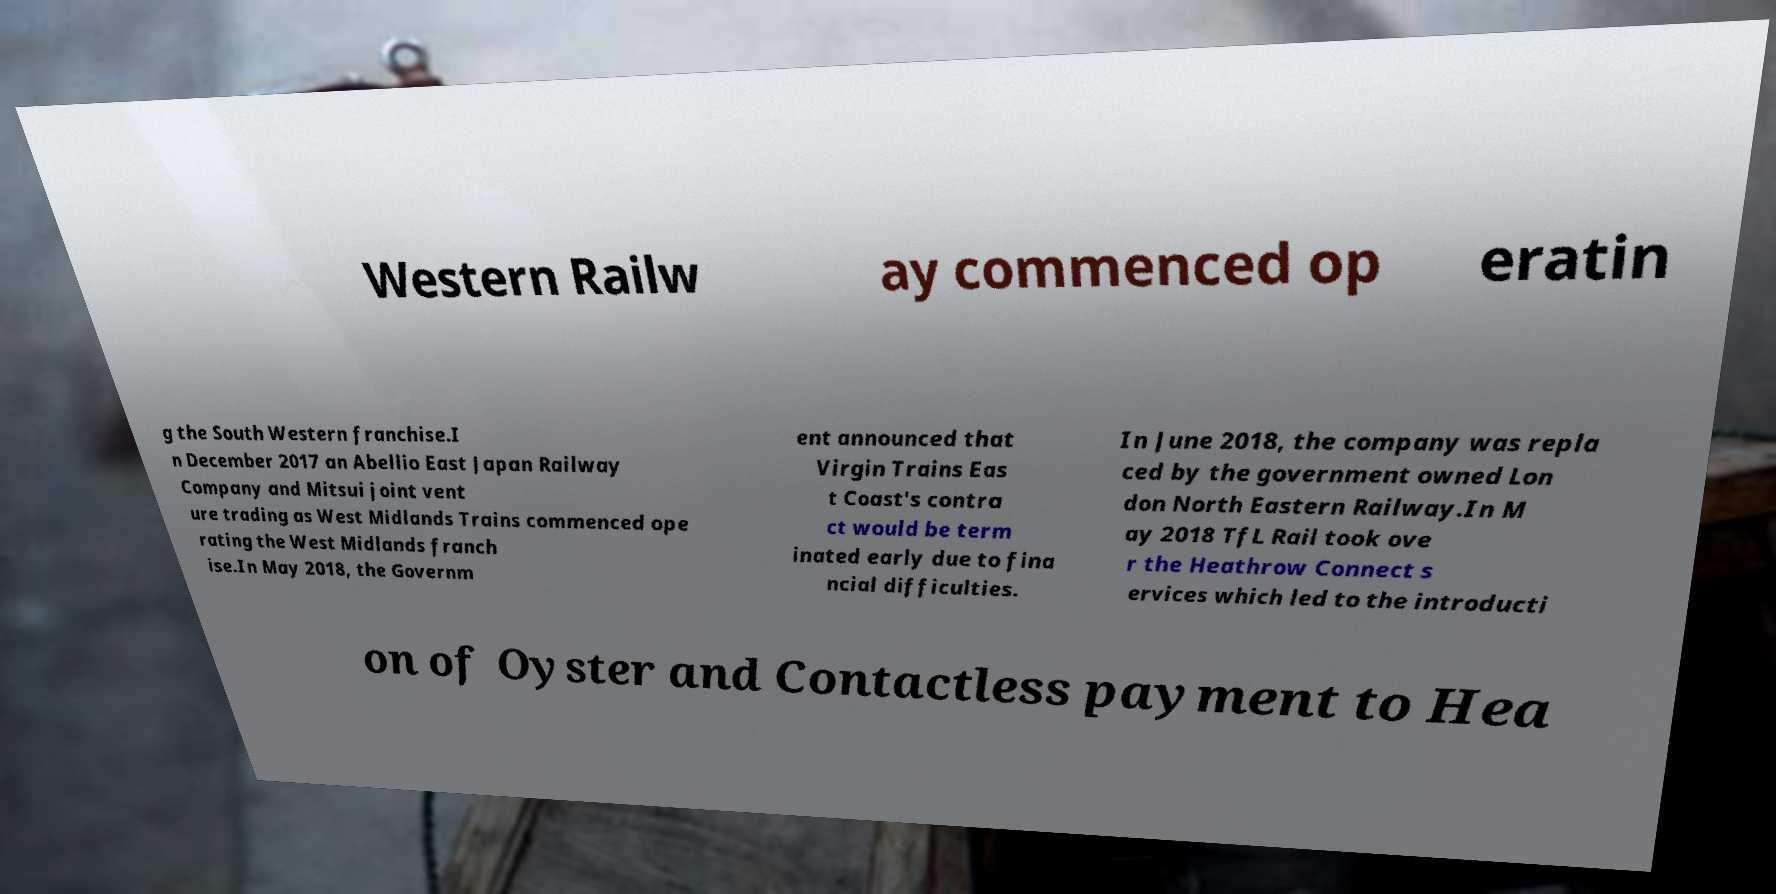Please read and relay the text visible in this image. What does it say? Western Railw ay commenced op eratin g the South Western franchise.I n December 2017 an Abellio East Japan Railway Company and Mitsui joint vent ure trading as West Midlands Trains commenced ope rating the West Midlands franch ise.In May 2018, the Governm ent announced that Virgin Trains Eas t Coast's contra ct would be term inated early due to fina ncial difficulties. In June 2018, the company was repla ced by the government owned Lon don North Eastern Railway.In M ay 2018 TfL Rail took ove r the Heathrow Connect s ervices which led to the introducti on of Oyster and Contactless payment to Hea 